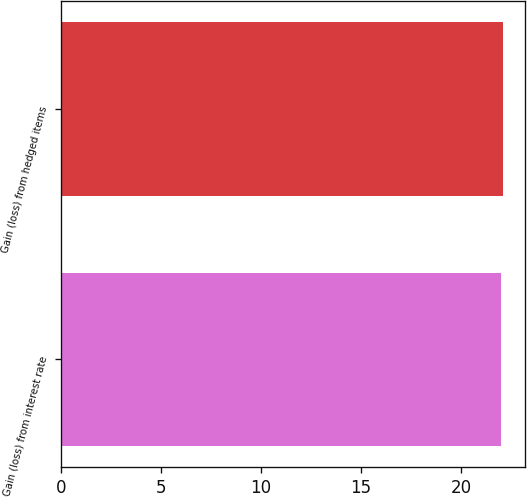<chart> <loc_0><loc_0><loc_500><loc_500><bar_chart><fcel>Gain (loss) from interest rate<fcel>Gain (loss) from hedged items<nl><fcel>22<fcel>22.1<nl></chart> 